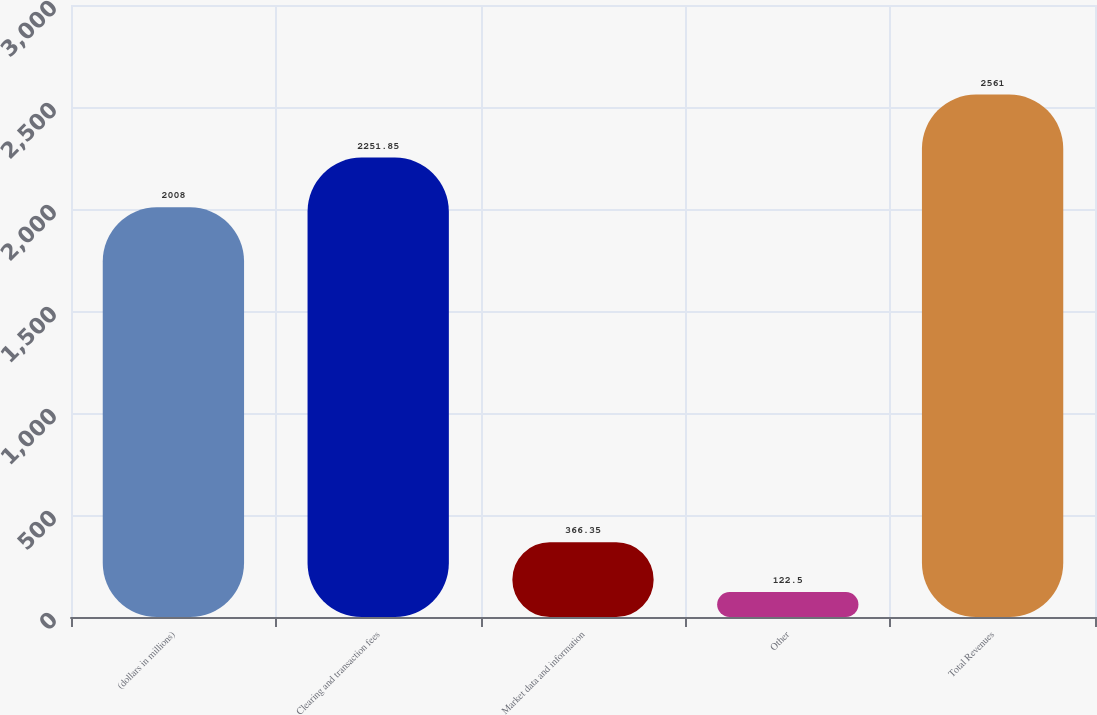Convert chart to OTSL. <chart><loc_0><loc_0><loc_500><loc_500><bar_chart><fcel>(dollars in millions)<fcel>Clearing and transaction fees<fcel>Market data and information<fcel>Other<fcel>Total Revenues<nl><fcel>2008<fcel>2251.85<fcel>366.35<fcel>122.5<fcel>2561<nl></chart> 